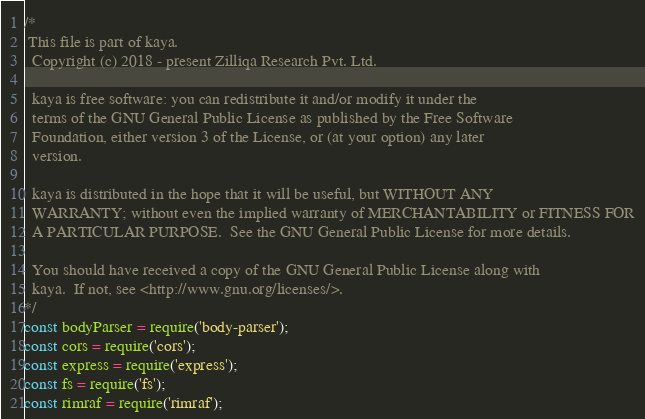<code> <loc_0><loc_0><loc_500><loc_500><_JavaScript_>/*
 This file is part of kaya.
  Copyright (c) 2018 - present Zilliqa Research Pvt. Ltd.

  kaya is free software: you can redistribute it and/or modify it under the
  terms of the GNU General Public License as published by the Free Software
  Foundation, either version 3 of the License, or (at your option) any later
  version.

  kaya is distributed in the hope that it will be useful, but WITHOUT ANY
  WARRANTY; without even the implied warranty of MERCHANTABILITY or FITNESS FOR
  A PARTICULAR PURPOSE.  See the GNU General Public License for more details.

  You should have received a copy of the GNU General Public License along with
  kaya.  If not, see <http://www.gnu.org/licenses/>.
*/
const bodyParser = require('body-parser');
const cors = require('cors');
const express = require('express');
const fs = require('fs');
const rimraf = require('rimraf');</code> 